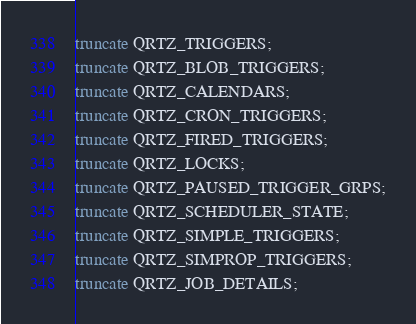Convert code to text. <code><loc_0><loc_0><loc_500><loc_500><_SQL_>truncate QRTZ_TRIGGERS;
truncate QRTZ_BLOB_TRIGGERS;
truncate QRTZ_CALENDARS;
truncate QRTZ_CRON_TRIGGERS;
truncate QRTZ_FIRED_TRIGGERS;
truncate QRTZ_LOCKS;
truncate QRTZ_PAUSED_TRIGGER_GRPS;
truncate QRTZ_SCHEDULER_STATE;
truncate QRTZ_SIMPLE_TRIGGERS;
truncate QRTZ_SIMPROP_TRIGGERS;
truncate QRTZ_JOB_DETAILS;</code> 